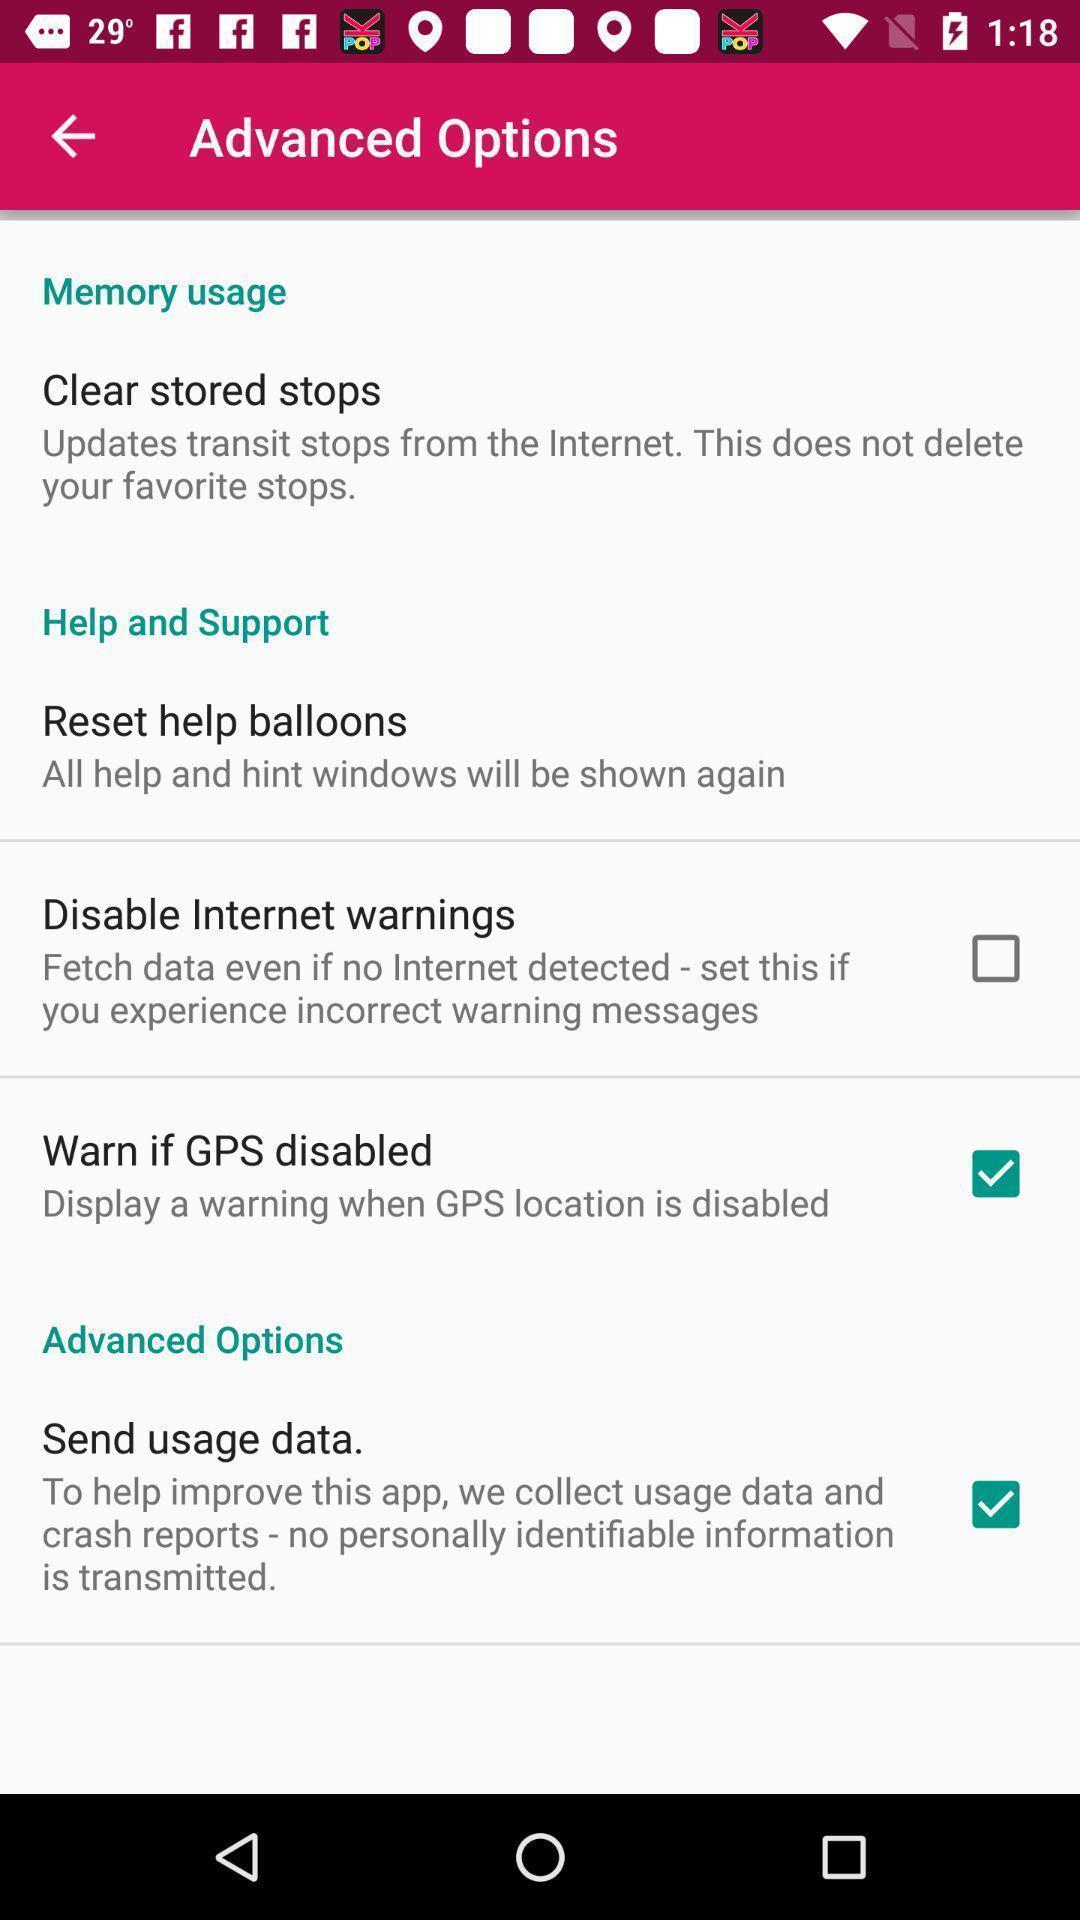Summarize the main components in this picture. Page displaying various advance options. 